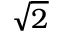<formula> <loc_0><loc_0><loc_500><loc_500>\sqrt { 2 }</formula> 